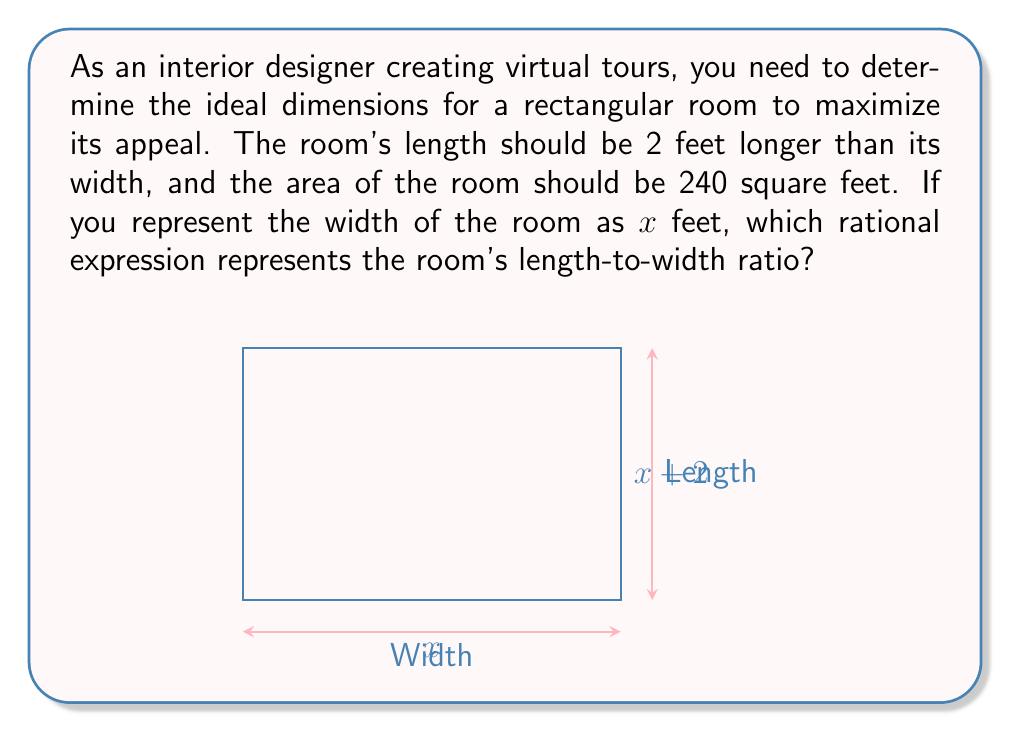Show me your answer to this math problem. Let's approach this step-by-step:

1) Let the width of the room be $x$ feet.
2) The length is 2 feet longer than the width, so it's $(x+2)$ feet.
3) The area of the room is 240 square feet, so we can set up the equation:
   $$ x(x+2) = 240 $$

4) To find the length-to-width ratio, we need to express the length in terms of the width:
   $$ \text{ratio} = \frac{\text{length}}{\text{width}} = \frac{x+2}{x} $$

5) This is already a rational expression, but we can simplify it further using the area equation:
   $$ x^2 + 2x = 240 $$
   $$ x^2 + 2x - 240 = 0 $$

6) Using the quadratic formula, we can solve for $x$:
   $$ x = \frac{-2 \pm \sqrt{4 + 4(240)}}{2} = \frac{-2 \pm \sqrt{964}}{2} $$

7) The positive solution (since width can't be negative) is:
   $$ x = \frac{-2 + \sqrt{964}}{2} \approx 14.9 $$

8) Therefore, the width is approximately 14.9 feet and the length is approximately 16.9 feet.

9) The final rational expression for the length-to-width ratio is:
   $$ \frac{x+2}{x} = \frac{14.9 + 2}{14.9} \approx 1.13 $$

This ratio represents the ideal proportion for the room in the virtual tour.
Answer: $\frac{x+2}{x}$ 